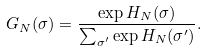Convert formula to latex. <formula><loc_0><loc_0><loc_500><loc_500>G _ { N } ( \sigma ) = \frac { \exp { H _ { N } ( \sigma ) } } { \sum _ { \sigma ^ { \prime } } \exp H _ { N } ( \sigma ^ { \prime } ) } .</formula> 